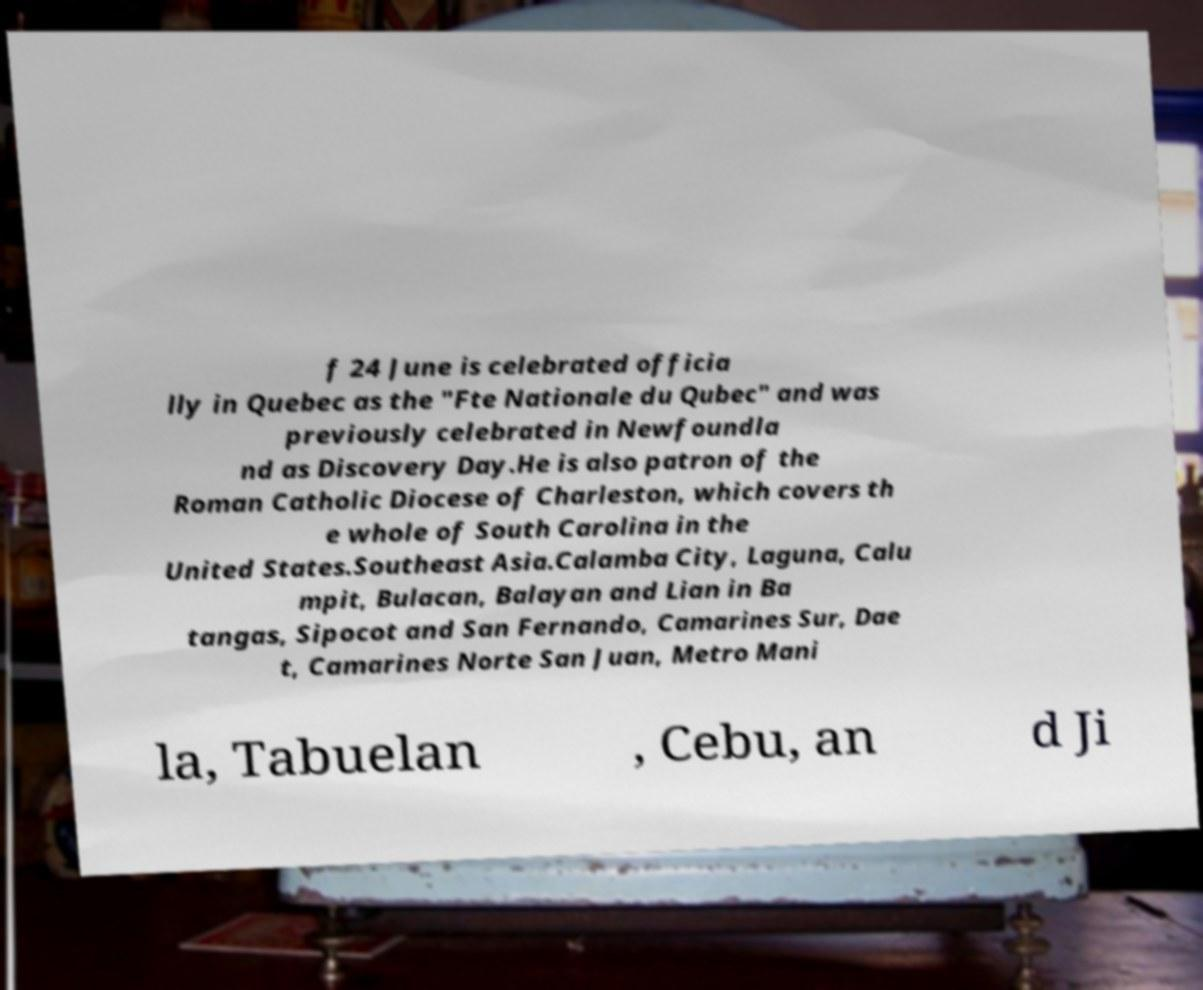Can you accurately transcribe the text from the provided image for me? f 24 June is celebrated officia lly in Quebec as the "Fte Nationale du Qubec" and was previously celebrated in Newfoundla nd as Discovery Day.He is also patron of the Roman Catholic Diocese of Charleston, which covers th e whole of South Carolina in the United States.Southeast Asia.Calamba City, Laguna, Calu mpit, Bulacan, Balayan and Lian in Ba tangas, Sipocot and San Fernando, Camarines Sur, Dae t, Camarines Norte San Juan, Metro Mani la, Tabuelan , Cebu, an d Ji 